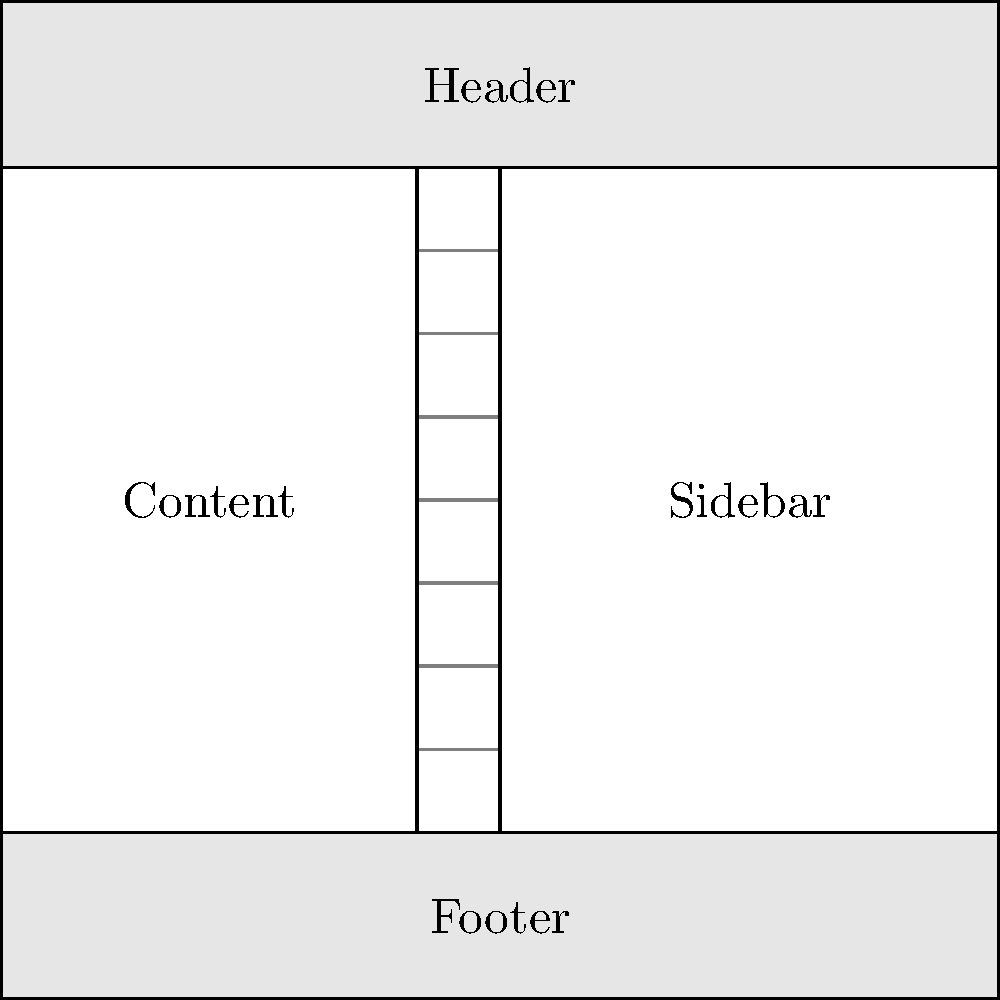In the given wireframe example of a website layout using a grid system, what is the ratio of the main content area width to the sidebar width? To determine the ratio of the main content area width to the sidebar width, we need to follow these steps:

1. Identify the main content area and sidebar in the wireframe.
   - The main content area is on the left side.
   - The sidebar is on the right side.

2. Count the grid columns for each section:
   - The main content area spans 5 grid columns.
   - The sidebar spans 6 grid columns.

3. Express the ratio of main content width to sidebar width:
   - Main content : Sidebar
   - 5 : 6

4. Simplify the ratio if possible:
   - In this case, 5:6 is already in its simplest form.

Therefore, the ratio of the main content area width to the sidebar width is 5:6.
Answer: 5:6 